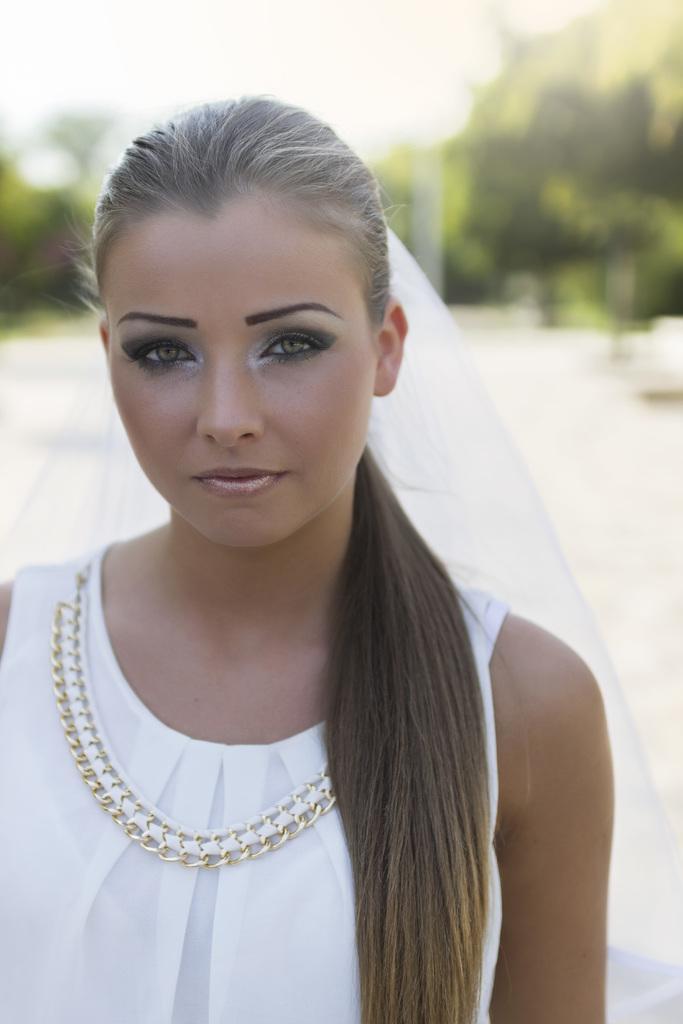Please provide a concise description of this image. In this image we can see a woman is standing, she is wearing the white color dress, at the back here are the trees. 